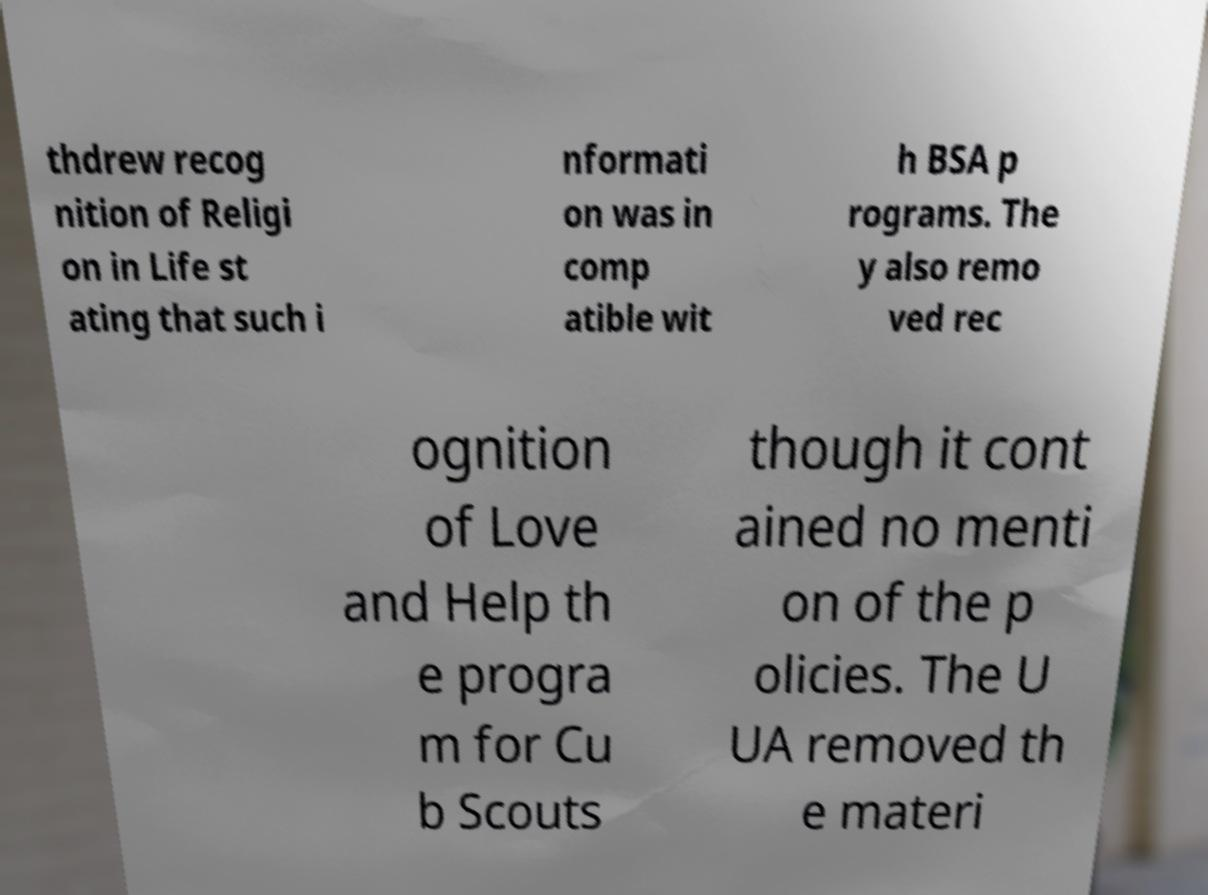For documentation purposes, I need the text within this image transcribed. Could you provide that? thdrew recog nition of Religi on in Life st ating that such i nformati on was in comp atible wit h BSA p rograms. The y also remo ved rec ognition of Love and Help th e progra m for Cu b Scouts though it cont ained no menti on of the p olicies. The U UA removed th e materi 